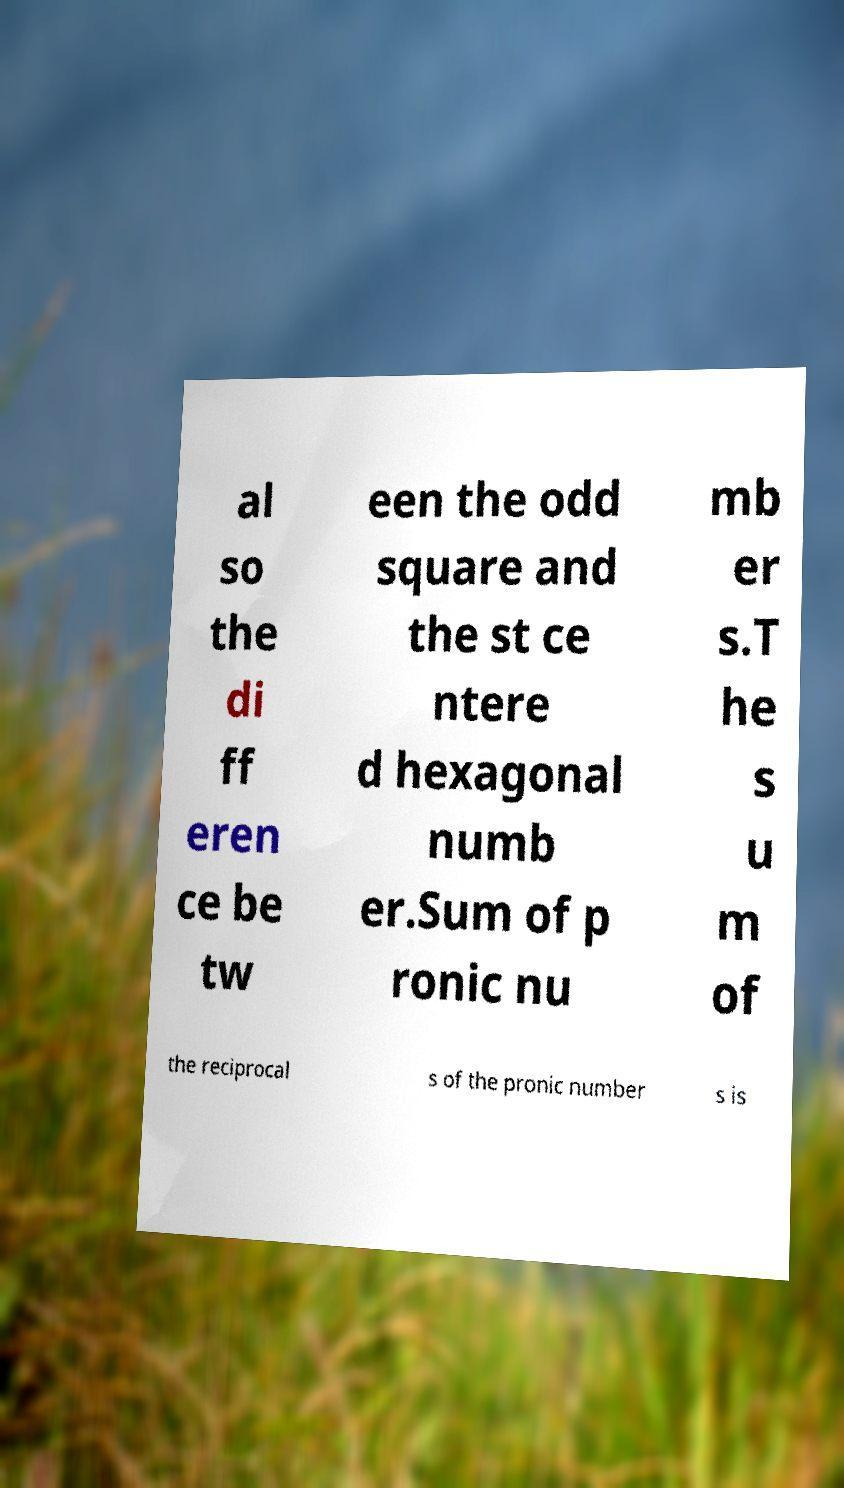For documentation purposes, I need the text within this image transcribed. Could you provide that? al so the di ff eren ce be tw een the odd square and the st ce ntere d hexagonal numb er.Sum of p ronic nu mb er s.T he s u m of the reciprocal s of the pronic number s is 